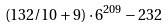<formula> <loc_0><loc_0><loc_500><loc_500>( 1 3 2 / 1 0 + 9 ) \cdot 6 ^ { 2 0 9 } - 2 3 2</formula> 